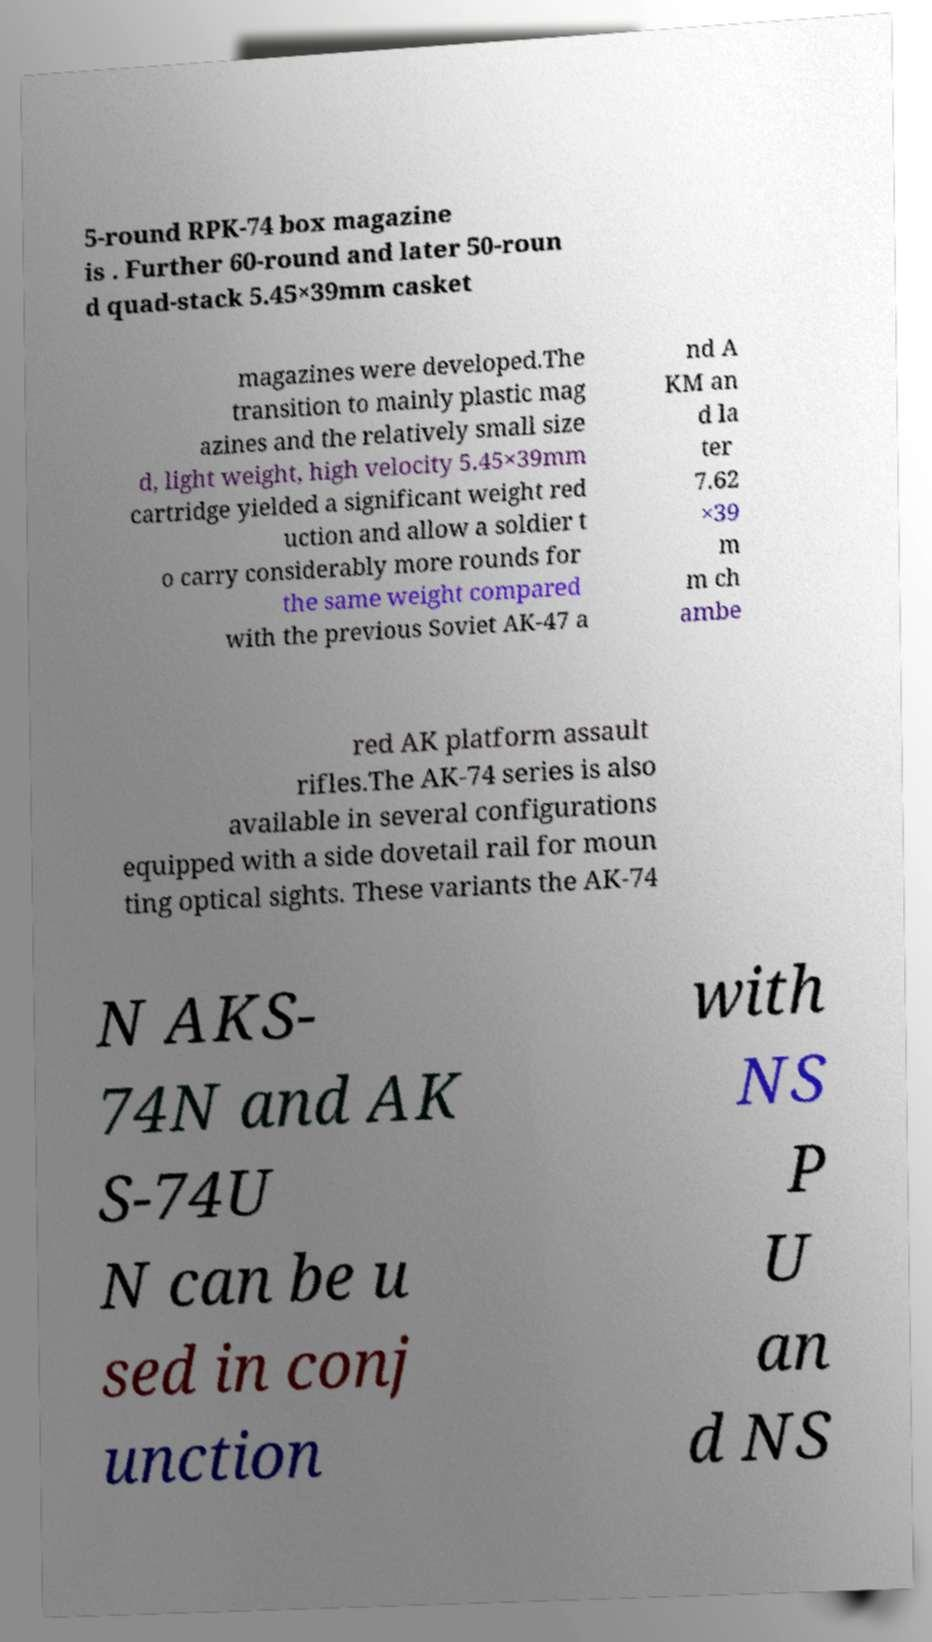For documentation purposes, I need the text within this image transcribed. Could you provide that? 5-round RPK-74 box magazine is . Further 60-round and later 50-roun d quad-stack 5.45×39mm casket magazines were developed.The transition to mainly plastic mag azines and the relatively small size d, light weight, high velocity 5.45×39mm cartridge yielded a significant weight red uction and allow a soldier t o carry considerably more rounds for the same weight compared with the previous Soviet AK-47 a nd A KM an d la ter 7.62 ×39 m m ch ambe red AK platform assault rifles.The AK-74 series is also available in several configurations equipped with a side dovetail rail for moun ting optical sights. These variants the AK-74 N AKS- 74N and AK S-74U N can be u sed in conj unction with NS P U an d NS 